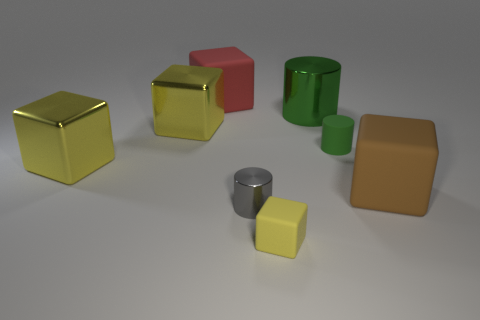How many large green cylinders have the same material as the large red thing?
Offer a very short reply. 0. There is a large matte block that is behind the large metal object that is right of the small rubber cube; are there any tiny blocks that are on the left side of it?
Ensure brevity in your answer.  No. There is a big green object; what shape is it?
Your answer should be very brief. Cylinder. Do the large red object to the left of the small gray metal cylinder and the small thing in front of the gray shiny cylinder have the same material?
Your answer should be compact. Yes. What number of small metal objects are the same color as the big cylinder?
Your response must be concise. 0. There is a big object that is to the right of the yellow rubber cube and to the left of the brown rubber block; what shape is it?
Offer a terse response. Cylinder. The matte cube that is both on the left side of the green matte thing and behind the tiny cube is what color?
Keep it short and to the point. Red. Is the number of small objects that are in front of the large brown rubber cube greater than the number of matte things on the right side of the small cube?
Make the answer very short. No. The big rubber block behind the big cylinder is what color?
Ensure brevity in your answer.  Red. Do the small object that is in front of the small gray cylinder and the shiny thing in front of the big brown matte block have the same shape?
Your answer should be very brief. No. 